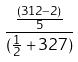<formula> <loc_0><loc_0><loc_500><loc_500>\frac { \frac { ( 3 1 2 - 2 ) } { 5 } } { ( \frac { 1 } { 2 } + 3 2 7 ) }</formula> 